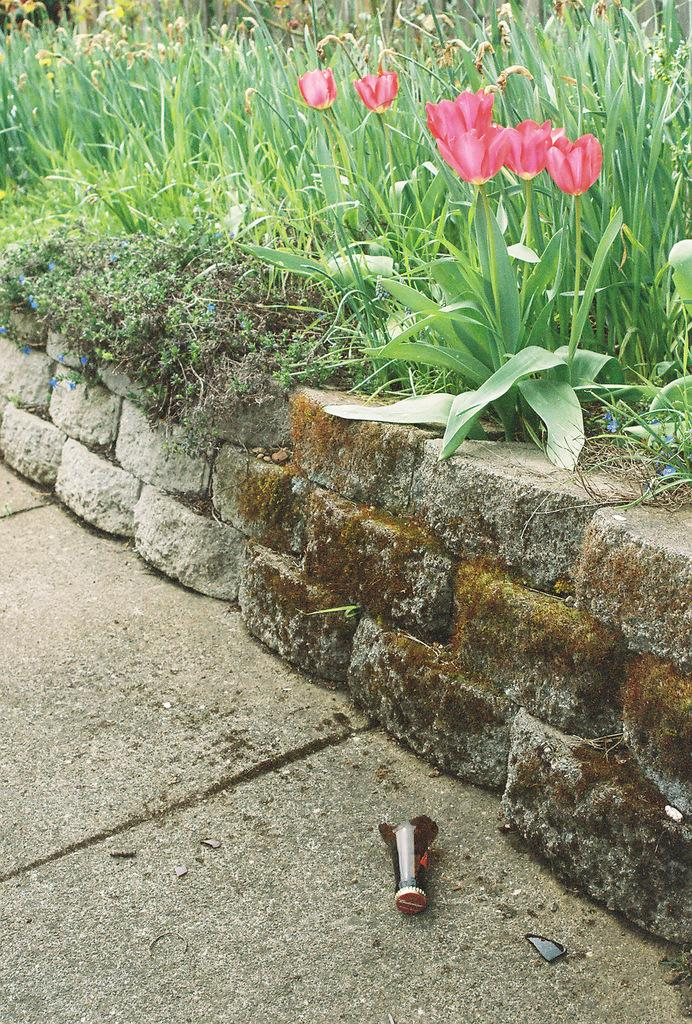What type of plants can be seen in the image? There are flowers in the image. What is the color of the grass in the background? The grass in the background is green. What material are the pieces on the floor made of? The pieces on the floor are made of glass. Where can the lizards be seen playing in the image? There are no lizards present in the image. What type of surface is the sidewalk in the image made of? There is no sidewalk present in the image. 